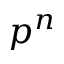<formula> <loc_0><loc_0><loc_500><loc_500>p ^ { n }</formula> 